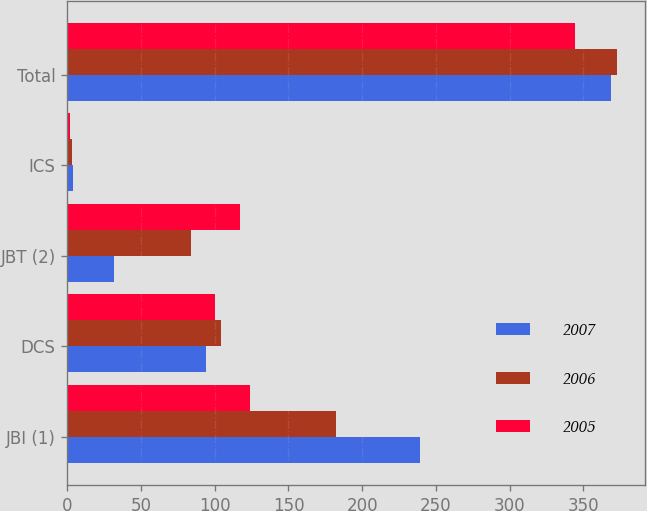Convert chart. <chart><loc_0><loc_0><loc_500><loc_500><stacked_bar_chart><ecel><fcel>JBI (1)<fcel>DCS<fcel>JBT (2)<fcel>ICS<fcel>Total<nl><fcel>2007<fcel>239<fcel>94<fcel>32<fcel>4<fcel>369<nl><fcel>2006<fcel>182<fcel>104<fcel>84<fcel>3<fcel>373<nl><fcel>2005<fcel>124<fcel>100<fcel>117<fcel>2<fcel>344<nl></chart> 